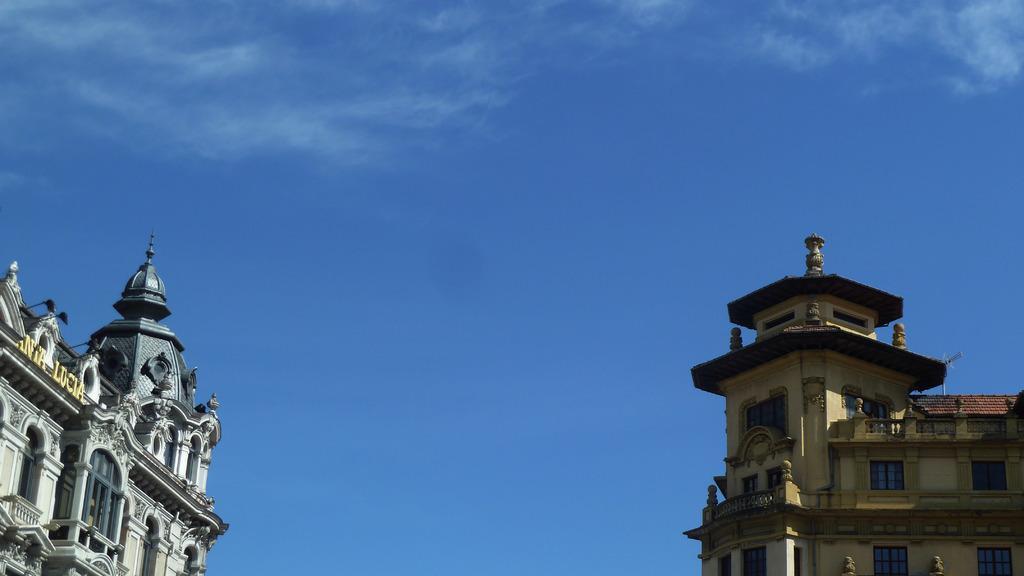In one or two sentences, can you explain what this image depicts? In this picture I can see there are two buildings at left and right sides. The building on the left side has sculpture, windows, the building on the right side has windows. The sky is clear. 